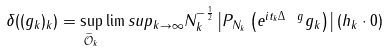<formula> <loc_0><loc_0><loc_500><loc_500>\delta ( ( g _ { k } ) _ { k } ) = \sup _ { \widetilde { \mathcal { O } } _ { k } } \lim s u p _ { k \to \infty } N _ { k } ^ { - \frac { 1 } { 2 } } \left | P _ { N _ { k } } \left ( e ^ { i t _ { k } \Delta _ { \ } g } g _ { k } \right ) \right | ( h _ { k } \cdot 0 )</formula> 